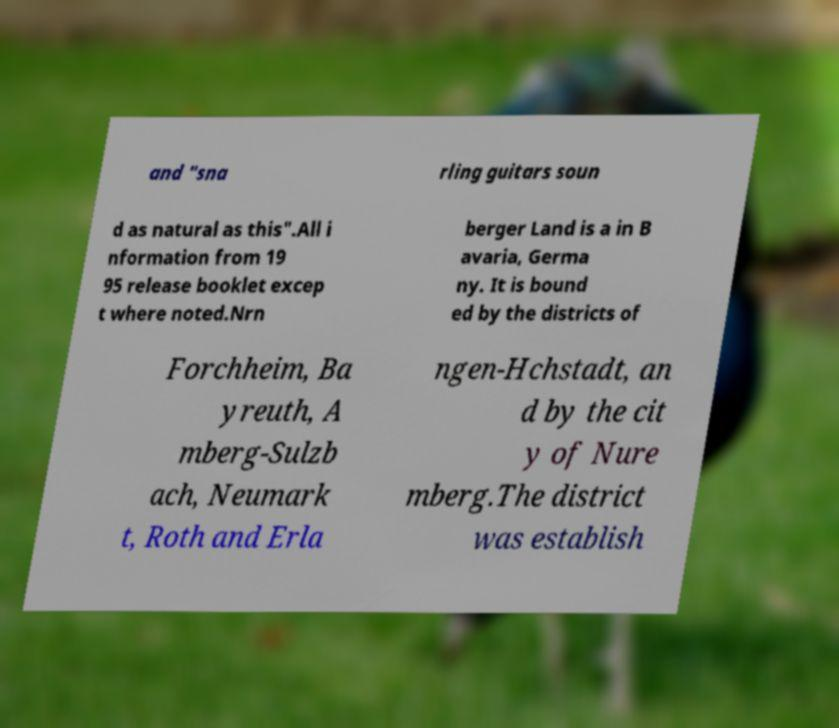I need the written content from this picture converted into text. Can you do that? and "sna rling guitars soun d as natural as this".All i nformation from 19 95 release booklet excep t where noted.Nrn berger Land is a in B avaria, Germa ny. It is bound ed by the districts of Forchheim, Ba yreuth, A mberg-Sulzb ach, Neumark t, Roth and Erla ngen-Hchstadt, an d by the cit y of Nure mberg.The district was establish 